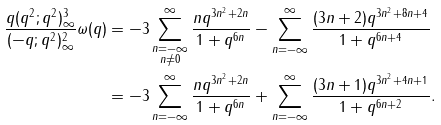<formula> <loc_0><loc_0><loc_500><loc_500>\frac { q ( q ^ { 2 } ; q ^ { 2 } ) _ { \infty } ^ { 3 } } { ( - q ; q ^ { 2 } ) _ { \infty } ^ { 2 } } \omega ( q ) & = - 3 \sum _ { \substack { n = - \infty \\ n \neq 0 } } ^ { \infty } \frac { n q ^ { 3 n ^ { 2 } + 2 n } } { 1 + q ^ { 6 n } } - \sum _ { n = - \infty } ^ { \infty } \frac { ( 3 n + 2 ) q ^ { 3 n ^ { 2 } + 8 n + 4 } } { 1 + q ^ { 6 n + 4 } } \\ & = - 3 \sum _ { n = - \infty } ^ { \infty } \frac { n q ^ { 3 n ^ { 2 } + 2 n } } { 1 + q ^ { 6 n } } + \sum _ { n = - \infty } ^ { \infty } \frac { ( 3 n + 1 ) q ^ { 3 n ^ { 2 } + 4 n + 1 } } { 1 + q ^ { 6 n + 2 } } .</formula> 